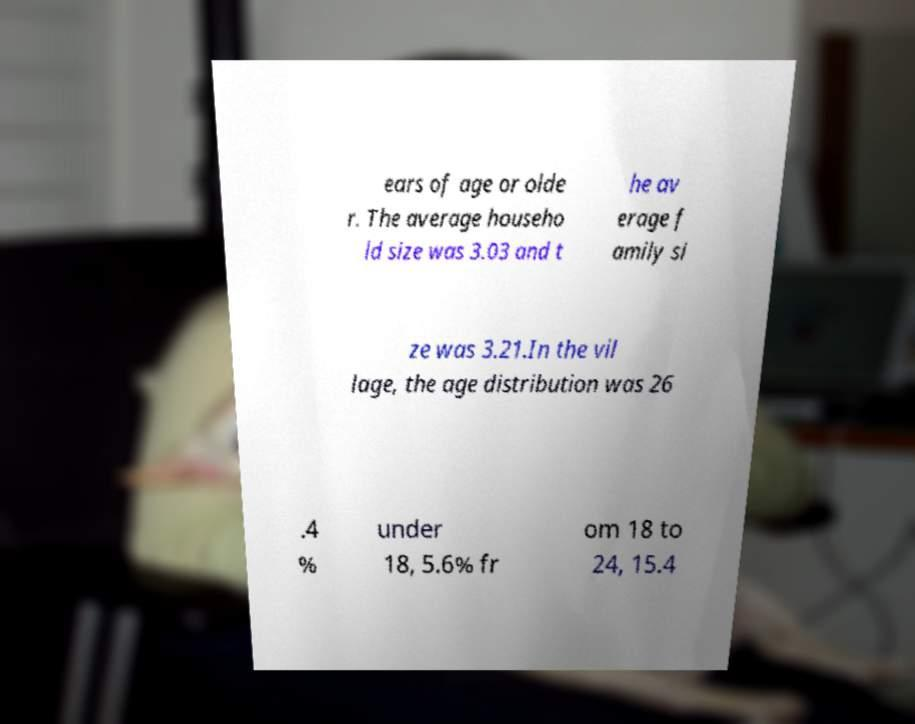There's text embedded in this image that I need extracted. Can you transcribe it verbatim? ears of age or olde r. The average househo ld size was 3.03 and t he av erage f amily si ze was 3.21.In the vil lage, the age distribution was 26 .4 % under 18, 5.6% fr om 18 to 24, 15.4 